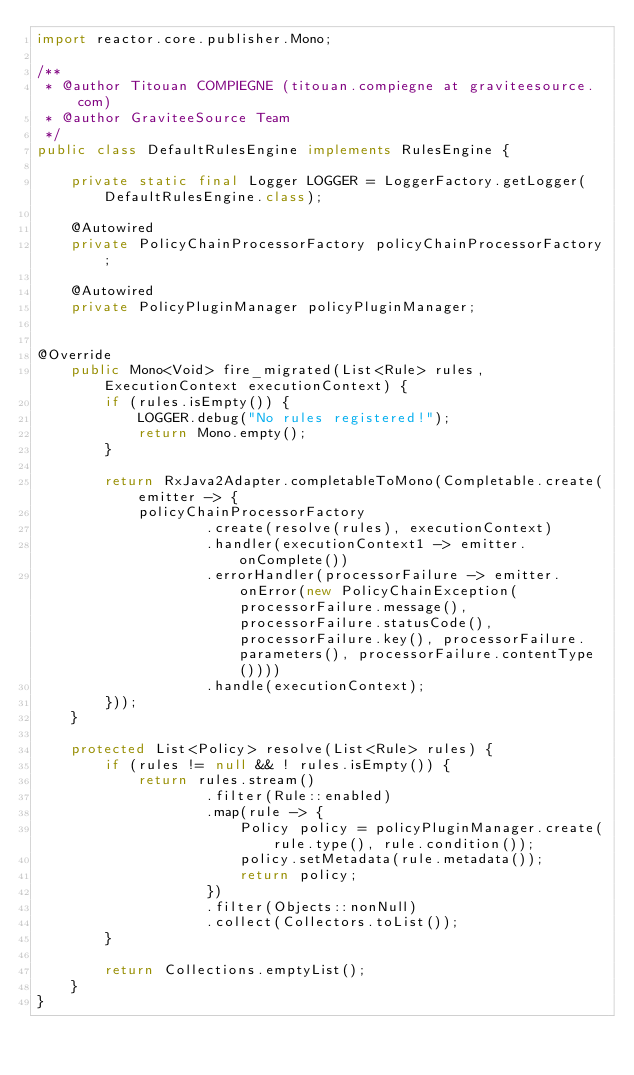<code> <loc_0><loc_0><loc_500><loc_500><_Java_>import reactor.core.publisher.Mono;

/**
 * @author Titouan COMPIEGNE (titouan.compiegne at graviteesource.com)
 * @author GraviteeSource Team
 */
public class DefaultRulesEngine implements RulesEngine {

    private static final Logger LOGGER = LoggerFactory.getLogger(DefaultRulesEngine.class);

    @Autowired
    private PolicyChainProcessorFactory policyChainProcessorFactory;

    @Autowired
    private PolicyPluginManager policyPluginManager;

    
@Override
    public Mono<Void> fire_migrated(List<Rule> rules, ExecutionContext executionContext) {
        if (rules.isEmpty()) {
            LOGGER.debug("No rules registered!");
            return Mono.empty();
        }

        return RxJava2Adapter.completableToMono(Completable.create(emitter -> {
            policyChainProcessorFactory
                    .create(resolve(rules), executionContext)
                    .handler(executionContext1 -> emitter.onComplete())
                    .errorHandler(processorFailure -> emitter.onError(new PolicyChainException(processorFailure.message(), processorFailure.statusCode(), processorFailure.key(), processorFailure.parameters(), processorFailure.contentType())))
                    .handle(executionContext);
        }));
    }

    protected List<Policy> resolve(List<Rule> rules) {
        if (rules != null && ! rules.isEmpty()) {
            return rules.stream()
                    .filter(Rule::enabled)
                    .map(rule -> {
                        Policy policy = policyPluginManager.create(rule.type(), rule.condition());
                        policy.setMetadata(rule.metadata());
                        return policy;
                    })
                    .filter(Objects::nonNull)
                    .collect(Collectors.toList());
        }

        return Collections.emptyList();
    }
}
</code> 